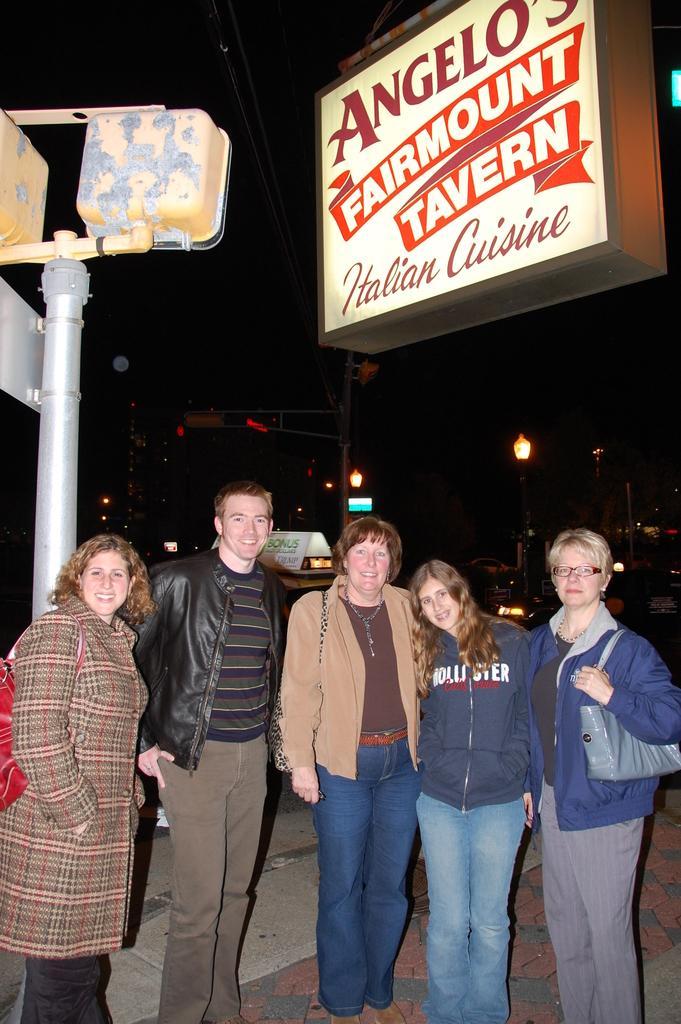How would you summarize this image in a sentence or two? In this image, I can see five persons standing and smiling. At the top left side of the image, I can see a pole. At the top right side of the image, there is a name board. There are light poles and I can see a dark background. 